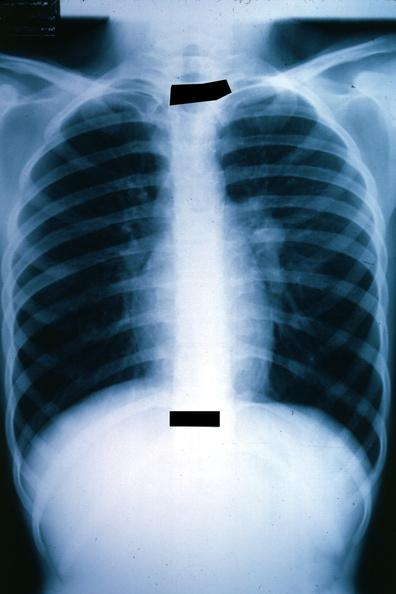s incidental finding present?
Answer the question using a single word or phrase. No 